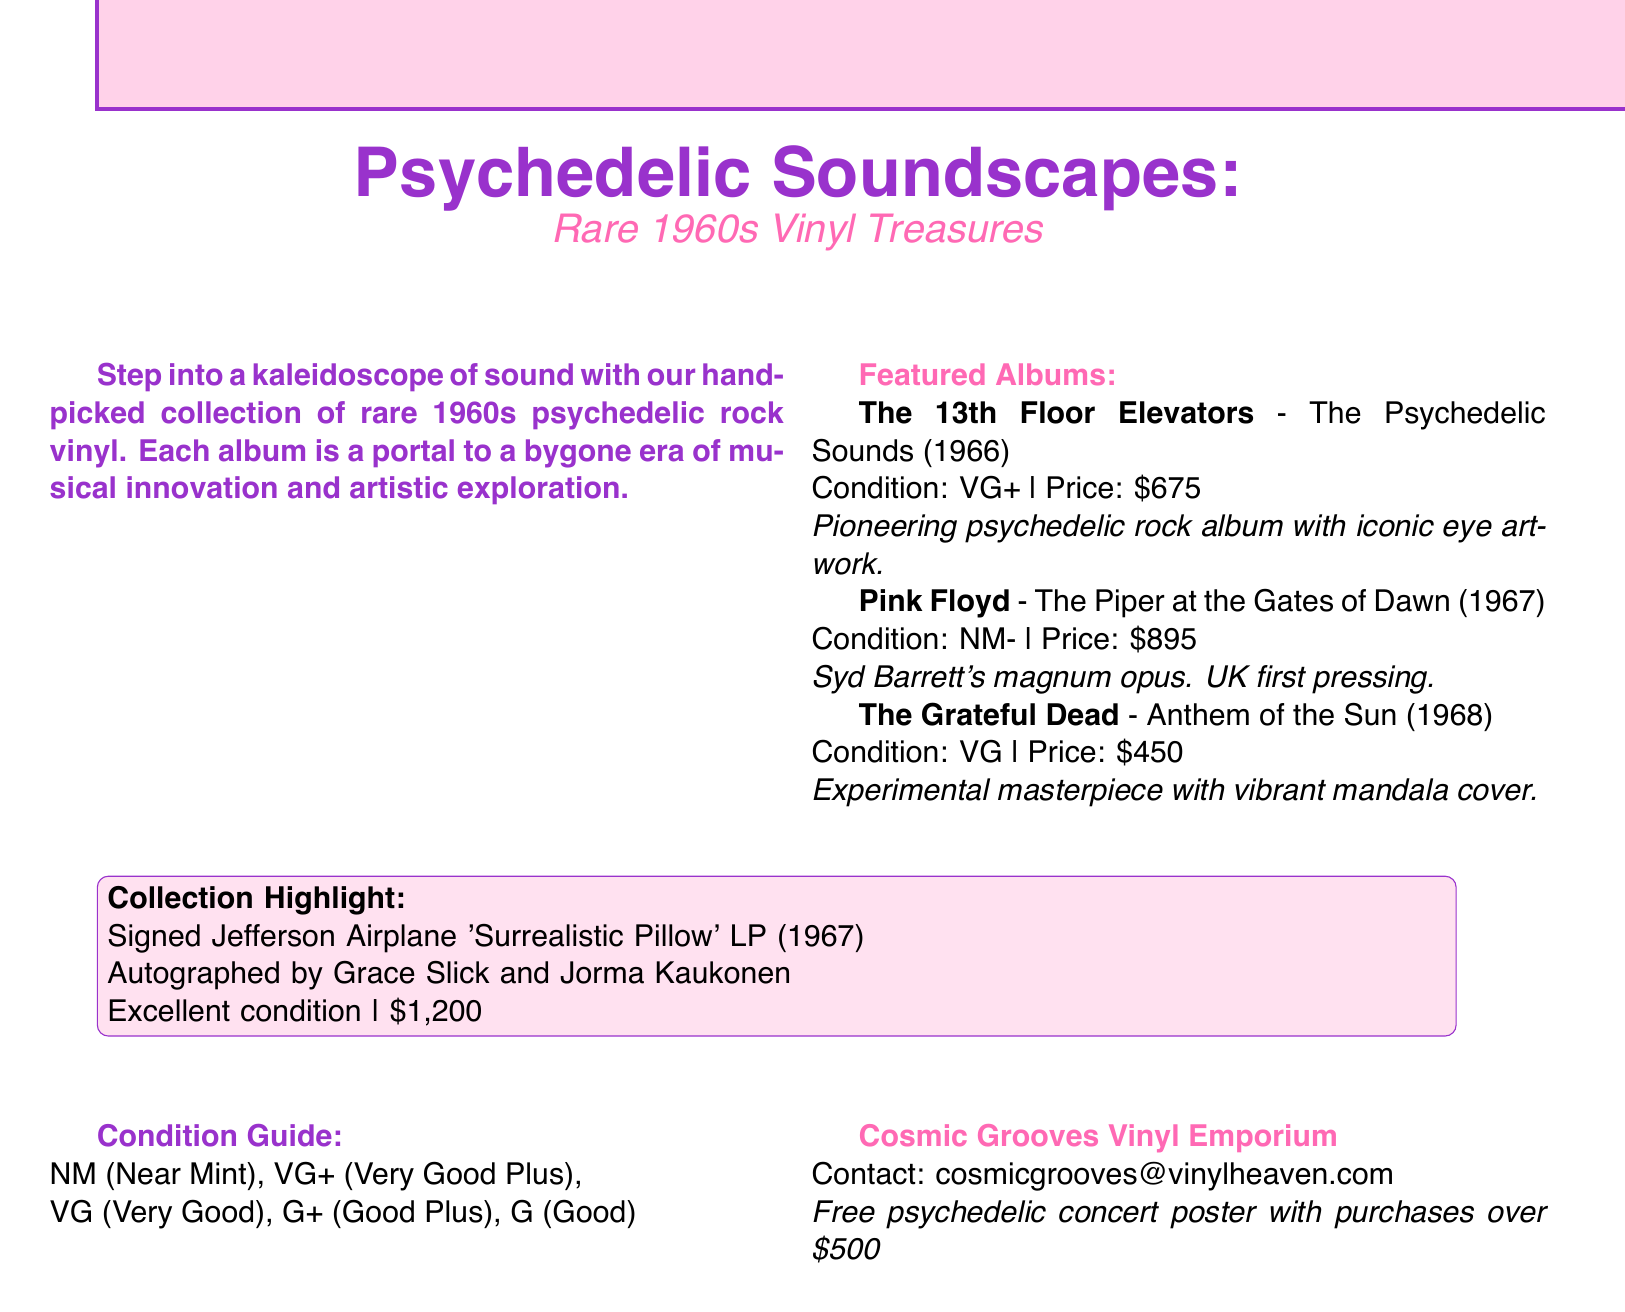What is the price of The Grateful Dead's album? The price is explicitly stated in the document for The Grateful Dead's album, which is $450.
Answer: $450 What condition is the Pink Floyd album in? The document specifies that the condition of the Pink Floyd album is NM-.
Answer: NM- Who is the featured artist for the signed collection highlight? The signed collection highlight mentions Grace Slick and Jorma Kaukonen as the autographed artists.
Answer: Grace Slick and Jorma Kaukonen What year was The Piper at the Gates of Dawn released? The release year of The Piper at the Gates of Dawn is indicated in the document as 1967.
Answer: 1967 How much is the signed Jefferson Airplane LP priced at? The document states the price for the signed Jefferson Airplane LP is $1,200.
Answer: $1,200 What is the condition rating for the album by The 13th Floor Elevators? The condition rating for the album by The 13th Floor Elevators is VG+.
Answer: VG+ What does NM stand for in the condition guide? NM in the condition guide stands for Near Mint, as described in the document.
Answer: Near Mint What promotional item is offered with purchases over $500? The document mentions that a free psychedelic concert poster is given with purchases over $500.
Answer: Free psychedelic concert poster 